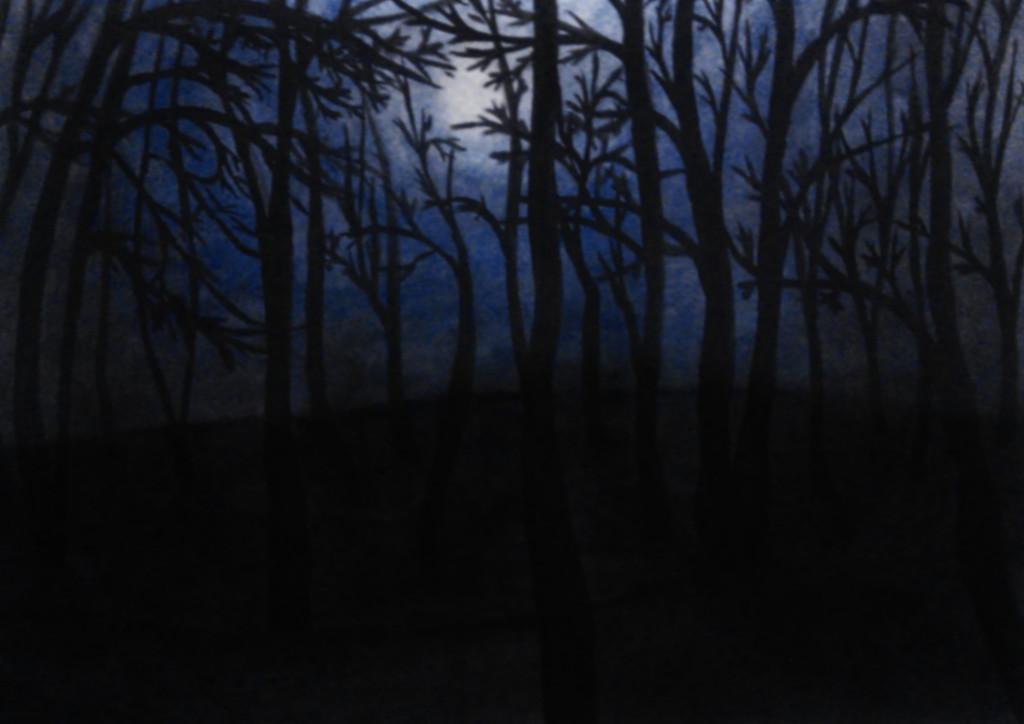In one or two sentences, can you explain what this image depicts? In this picture we can observe some trees. In the background there is a sky with clouds. The image was taken in the dim light. 